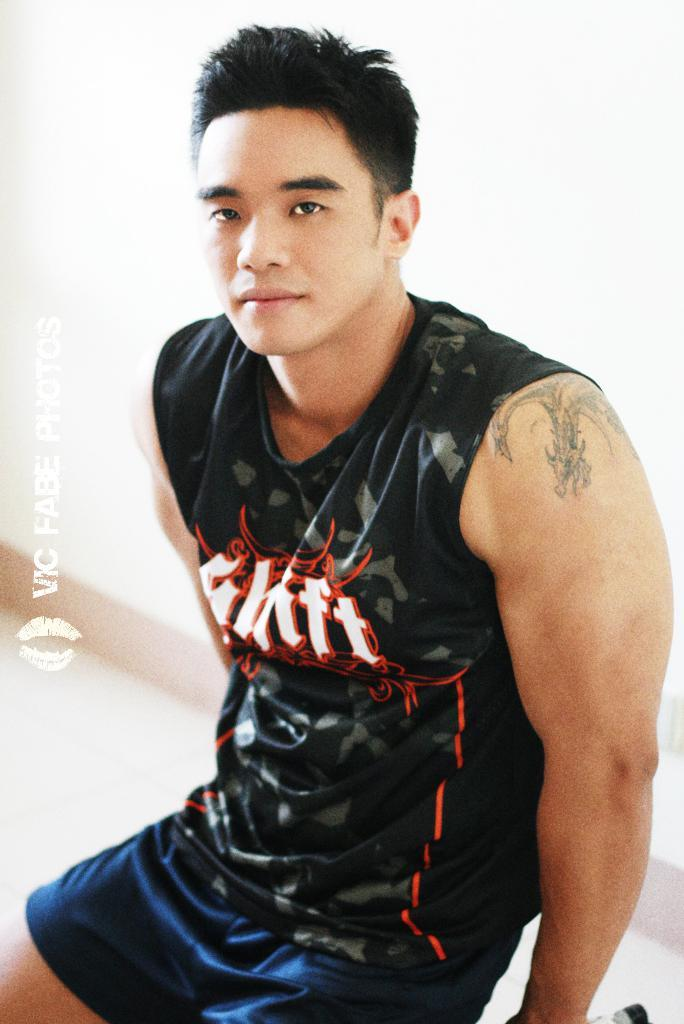<image>
Present a compact description of the photo's key features. An Asian man wearing a sleeveless black tshirt with a logo reading Shift 